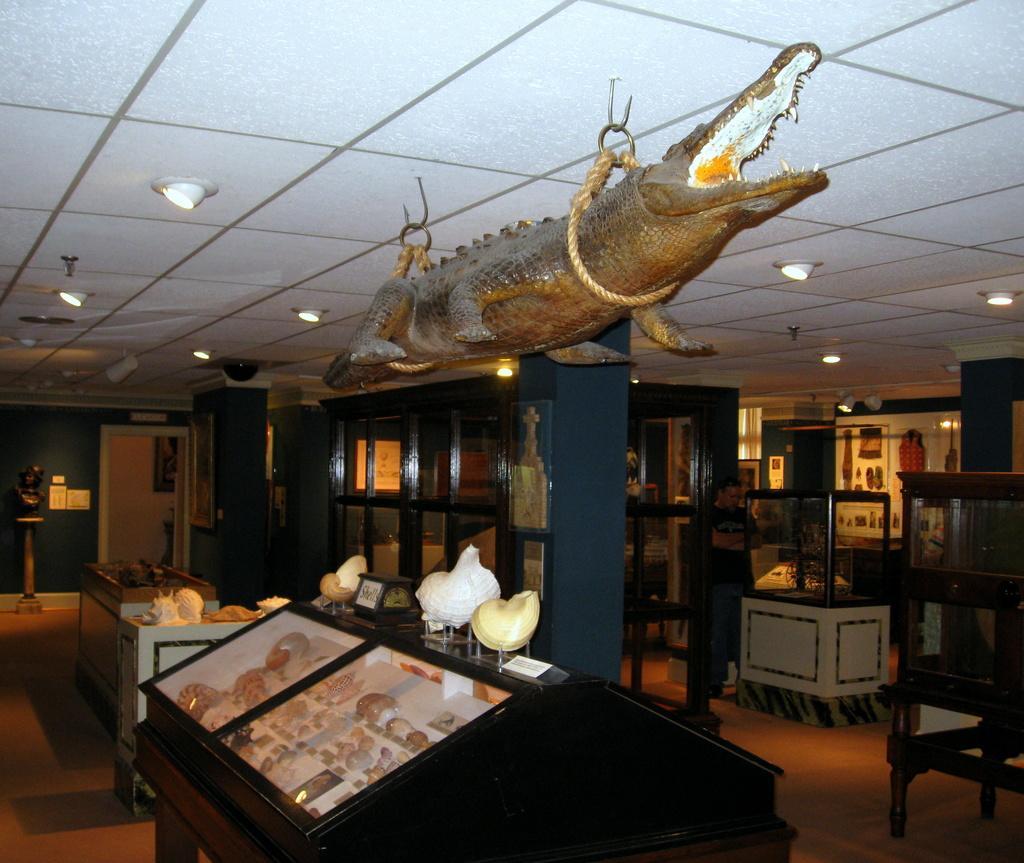In one or two sentences, can you explain what this image depicts? There is a statue of a crocodile tightened to a rope and attached above it and there are few other objects below it. 